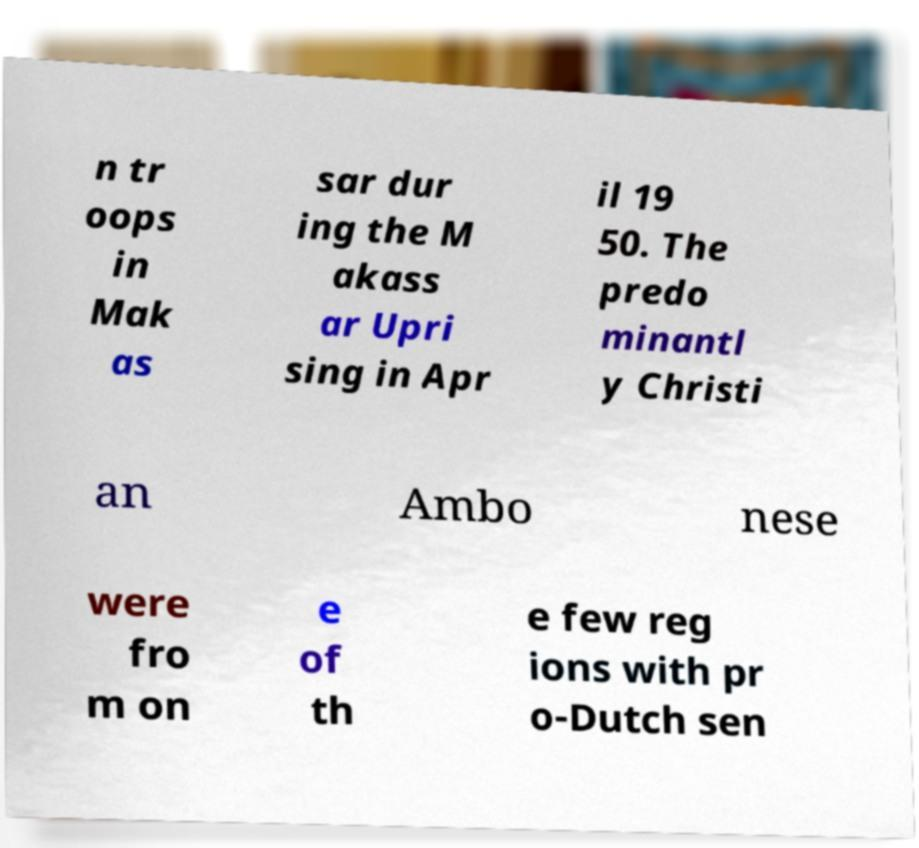Could you extract and type out the text from this image? n tr oops in Mak as sar dur ing the M akass ar Upri sing in Apr il 19 50. The predo minantl y Christi an Ambo nese were fro m on e of th e few reg ions with pr o-Dutch sen 